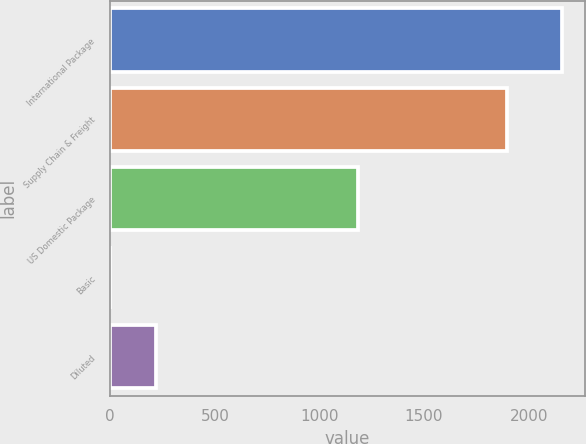Convert chart. <chart><loc_0><loc_0><loc_500><loc_500><bar_chart><fcel>International Package<fcel>Supply Chain & Freight<fcel>US Domestic Package<fcel>Basic<fcel>Diluted<nl><fcel>2161<fcel>1897<fcel>1185<fcel>0.89<fcel>216.9<nl></chart> 